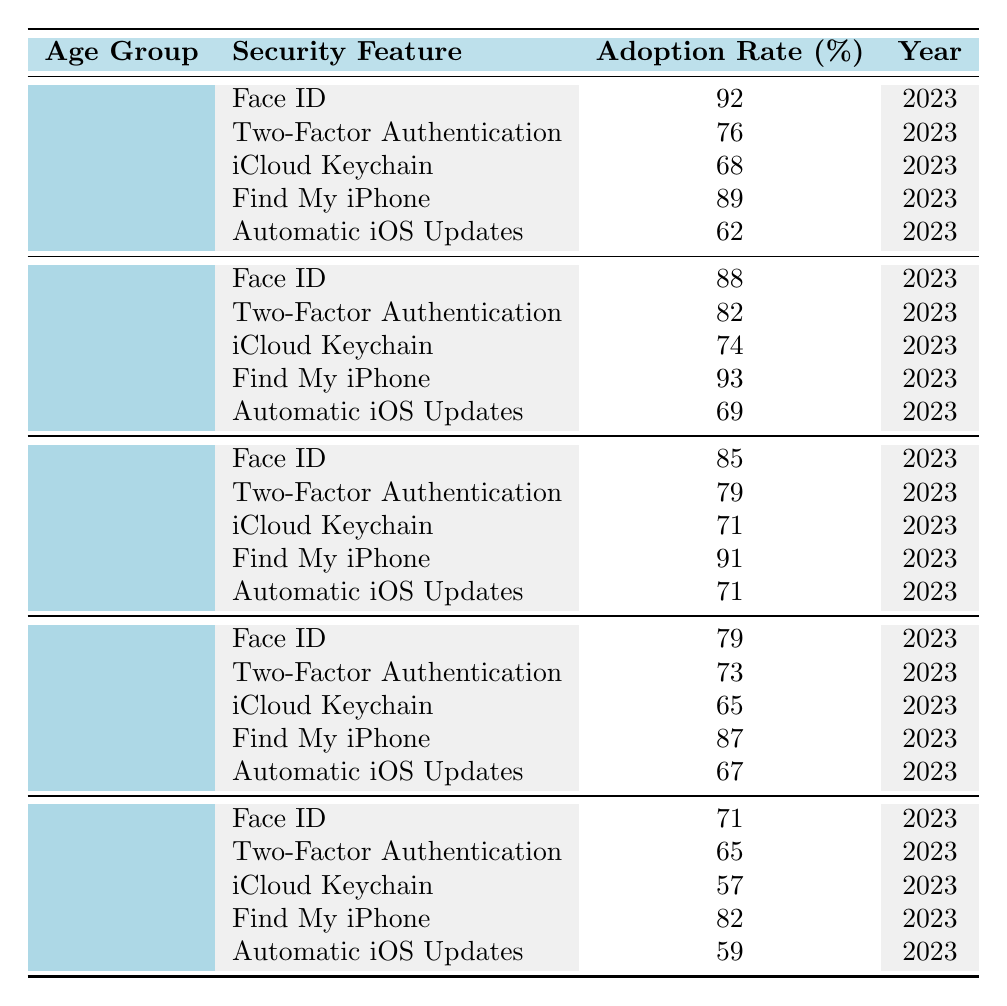What is the adoption rate of Face ID among the 18-24 age group? The table shows that the adoption rate of Face ID for the 18-24 age group is 92%.
Answer: 92% Which age group has the highest adoption rate for iCloud Keychain? The table indicates that the age group 25-34 has the highest adoption rate for iCloud Keychain at 74%.
Answer: 25-34 What is the average adoption rate of Two-Factor Authentication across all age groups? The adoption rates for Two-Factor Authentication are 76%, 82%, 79%, 73%, and 65%. Adding these gives 375%, and dividing by 5 results in an average of 75%.
Answer: 75% Is the adoption rate for Automatic iOS Updates higher among the 35-44 age group compared to the 55+ age group? The adoption rate for Automatic iOS Updates for the 35-44 age group is 71%, while for the 55+ age group, it is 59%. Thus, it is higher.
Answer: Yes What is the difference in adoption rates of Face ID between the 25-34 and 45-54 age groups? The Face ID adoption rate for the 25-34 age group is 88%, and for the 45-54 age group, it is 79%. The difference is 88% - 79% = 9%.
Answer: 9% How does the adoption rate of Find My iPhone compare between the youngest and oldest age groups? The adoption rate for Find My iPhone for the 18-24 age group is 89%, while for the 55+ age group, it is 82%. The difference is 89% - 82% = 7%, meaning the younger group has a higher rate.
Answer: 7% Which security feature shows the lowest adoption rate among the 55+ age group? The table lists the adoption rates for the 55+ age group as 71% (Face ID), 65% (Two-Factor Authentication), 57% (iCloud Keychain), 82% (Find My iPhone), and 59% (Automatic iOS Updates). The lowest is 57% for iCloud Keychain.
Answer: iCloud Keychain What is the cumulative adoption rate of Find My iPhone across all age groups? The adoption rates for Find My iPhone are 89%, 93%, 91%, 87%, and 82%. Adding these gives 442%.
Answer: 442% Among users aged 35-44, which security feature has the closest adoption rate to Two-Factor Authentication? The Two-Factor Authentication adoption rate for the 35-44 age group is 79%. The rates for Face ID, iCloud Keychain, Find My iPhone, and Automatic iOS Updates are 85%, 71%, 91%, and 71%, respectively. The closest is Automatic iOS Updates at 71%, a difference of 8%.
Answer: 8% Is the adoption of iCloud Keychain consistent across all age groups? The adoption rates for iCloud Keychain are 68%, 74%, 71%, 65%, and 57%, showing a decreasing trend rather than consistency.
Answer: No 